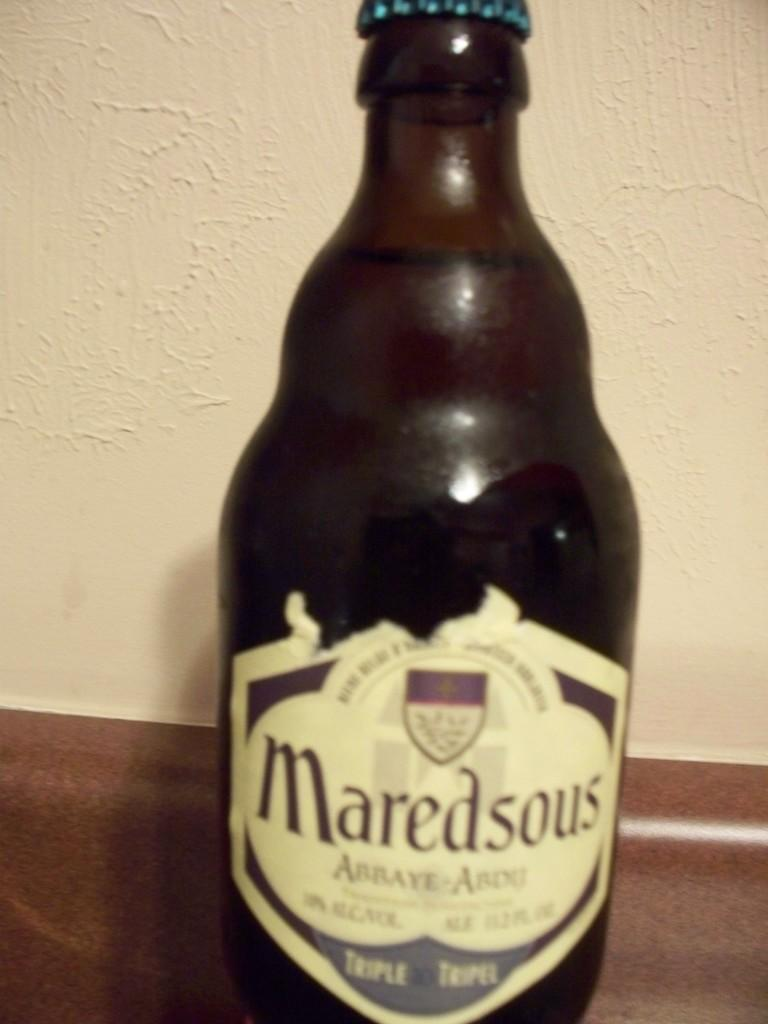<image>
Relay a brief, clear account of the picture shown. a bottle of Maredsous liquo with a somewhat torn label. 